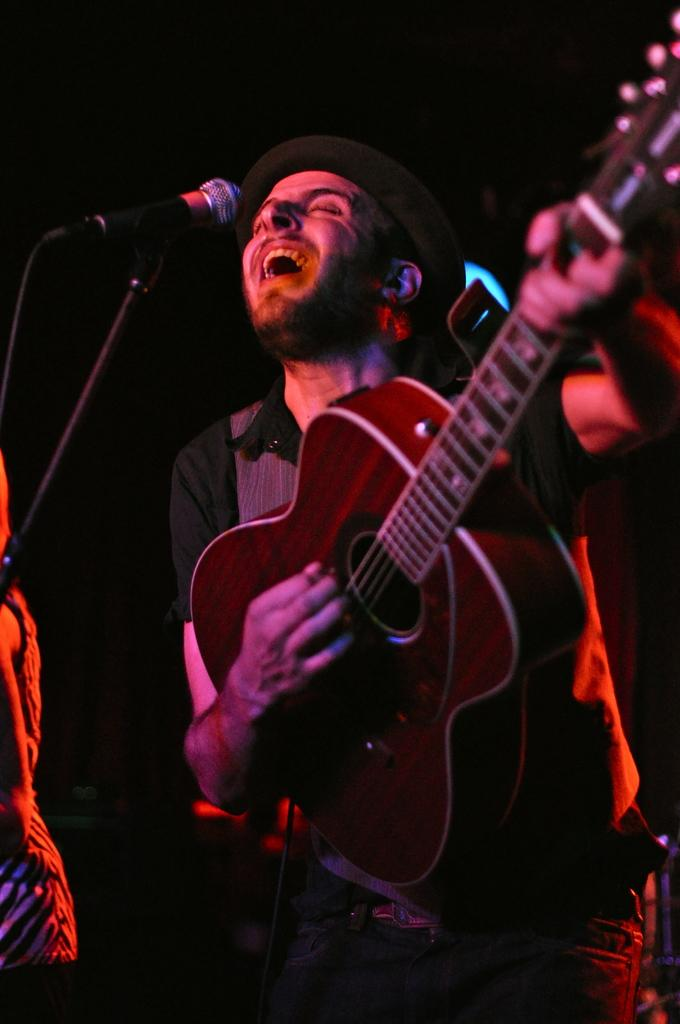What is the person in the image wearing on their upper body? The person is wearing a black shirt in the image. What type of headwear is the person wearing? The person is wearing a hat in the image. What activity is the person in the image engaged in? The person is singing in front of a microphone in the image. Can you describe the person standing at the left side of the image? There is another person standing at the left side of the image, but no specific details about them are provided. What is the color of the background in the image? The background in the image is black. What type of currency exchange is taking place in the image? There is no currency exchange taking place in the image; it features a person singing in front of a microphone. What type of medical operation is being performed in the image? There is no medical operation being performed in the image; it features a person singing in front of a microphone. 